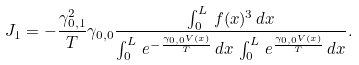<formula> <loc_0><loc_0><loc_500><loc_500>J _ { 1 } = - \frac { \gamma _ { 0 , 1 } ^ { 2 } } { T } \gamma _ { 0 , 0 } \frac { \int _ { 0 } ^ { L } \, f ( x ) ^ { 3 } \, d x } { \int _ { 0 } ^ { L } \, e ^ { - \frac { \gamma _ { 0 , 0 } V ( x ) } { T } } \, d x \, \int _ { 0 } ^ { L } \, e ^ { \frac { \gamma _ { 0 , 0 } V ( x ) } { T } } \, d x } .</formula> 